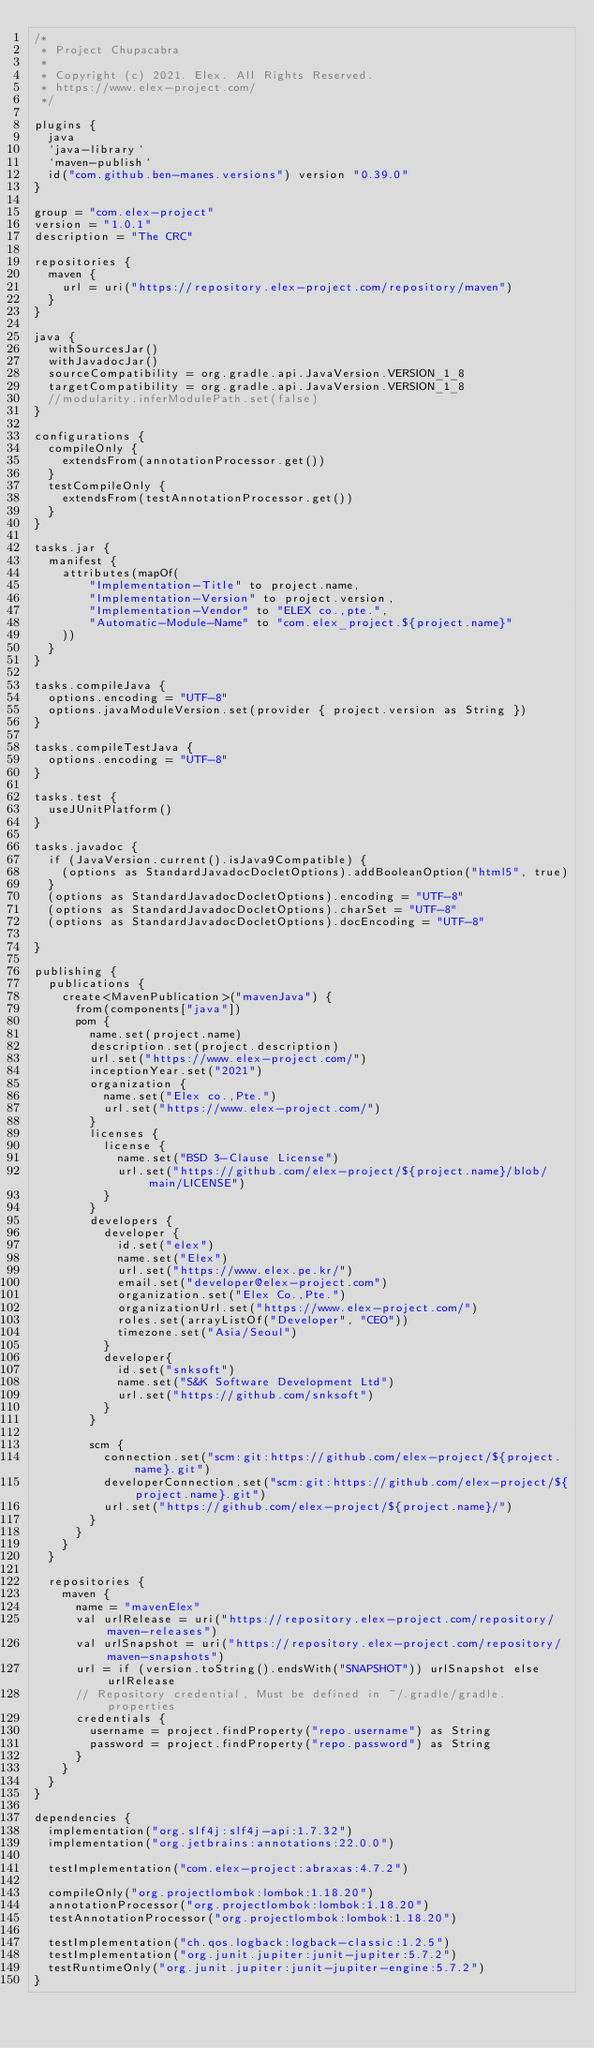Convert code to text. <code><loc_0><loc_0><loc_500><loc_500><_Kotlin_>/*
 * Project Chupacabra
 *
 * Copyright (c) 2021. Elex. All Rights Reserved.
 * https://www.elex-project.com/
 */

plugins {
	java
	`java-library`
	`maven-publish`
	id("com.github.ben-manes.versions") version "0.39.0"
}

group = "com.elex-project"
version = "1.0.1"
description = "The CRC"

repositories {
	maven {
		url = uri("https://repository.elex-project.com/repository/maven")
	}
}

java {
	withSourcesJar()
	withJavadocJar()
	sourceCompatibility = org.gradle.api.JavaVersion.VERSION_1_8
	targetCompatibility = org.gradle.api.JavaVersion.VERSION_1_8
	//modularity.inferModulePath.set(false)
}

configurations {
	compileOnly {
		extendsFrom(annotationProcessor.get())
	}
	testCompileOnly {
		extendsFrom(testAnnotationProcessor.get())
	}
}

tasks.jar {
	manifest {
		attributes(mapOf(
				"Implementation-Title" to project.name,
				"Implementation-Version" to project.version,
				"Implementation-Vendor" to "ELEX co.,pte.",
				"Automatic-Module-Name" to "com.elex_project.${project.name}"
		))
	}
}

tasks.compileJava {
	options.encoding = "UTF-8"
	options.javaModuleVersion.set(provider { project.version as String })
}

tasks.compileTestJava {
	options.encoding = "UTF-8"
}

tasks.test {
	useJUnitPlatform()
}

tasks.javadoc {
	if (JavaVersion.current().isJava9Compatible) {
		(options as StandardJavadocDocletOptions).addBooleanOption("html5", true)
	}
	(options as StandardJavadocDocletOptions).encoding = "UTF-8"
	(options as StandardJavadocDocletOptions).charSet = "UTF-8"
	(options as StandardJavadocDocletOptions).docEncoding = "UTF-8"

}

publishing {
	publications {
		create<MavenPublication>("mavenJava") {
			from(components["java"])
			pom {
				name.set(project.name)
				description.set(project.description)
				url.set("https://www.elex-project.com/")
				inceptionYear.set("2021")
				organization {
					name.set("Elex co.,Pte.")
					url.set("https://www.elex-project.com/")
				}
				licenses {
					license {
						name.set("BSD 3-Clause License")
						url.set("https://github.com/elex-project/${project.name}/blob/main/LICENSE")
					}
				}
				developers {
					developer {
						id.set("elex")
						name.set("Elex")
						url.set("https://www.elex.pe.kr/")
						email.set("developer@elex-project.com")
						organization.set("Elex Co.,Pte.")
						organizationUrl.set("https://www.elex-project.com/")
						roles.set(arrayListOf("Developer", "CEO"))
						timezone.set("Asia/Seoul")
					}
					developer{
						id.set("snksoft")
						name.set("S&K Software Development Ltd")
						url.set("https://github.com/snksoft")
					}
				}

				scm {
					connection.set("scm:git:https://github.com/elex-project/${project.name}.git")
					developerConnection.set("scm:git:https://github.com/elex-project/${project.name}.git")
					url.set("https://github.com/elex-project/${project.name}/")
				}
			}
		}
	}

	repositories {
		maven {
			name = "mavenElex"
			val urlRelease = uri("https://repository.elex-project.com/repository/maven-releases")
			val urlSnapshot = uri("https://repository.elex-project.com/repository/maven-snapshots")
			url = if (version.toString().endsWith("SNAPSHOT")) urlSnapshot else urlRelease
			// Repository credential, Must be defined in ~/.gradle/gradle.properties
			credentials {
				username = project.findProperty("repo.username") as String
				password = project.findProperty("repo.password") as String
			}
		}
	}
}

dependencies {
	implementation("org.slf4j:slf4j-api:1.7.32")
	implementation("org.jetbrains:annotations:22.0.0")

	testImplementation("com.elex-project:abraxas:4.7.2")

	compileOnly("org.projectlombok:lombok:1.18.20")
	annotationProcessor("org.projectlombok:lombok:1.18.20")
	testAnnotationProcessor("org.projectlombok:lombok:1.18.20")

	testImplementation("ch.qos.logback:logback-classic:1.2.5")
	testImplementation("org.junit.jupiter:junit-jupiter:5.7.2")
	testRuntimeOnly("org.junit.jupiter:junit-jupiter-engine:5.7.2")
}
</code> 